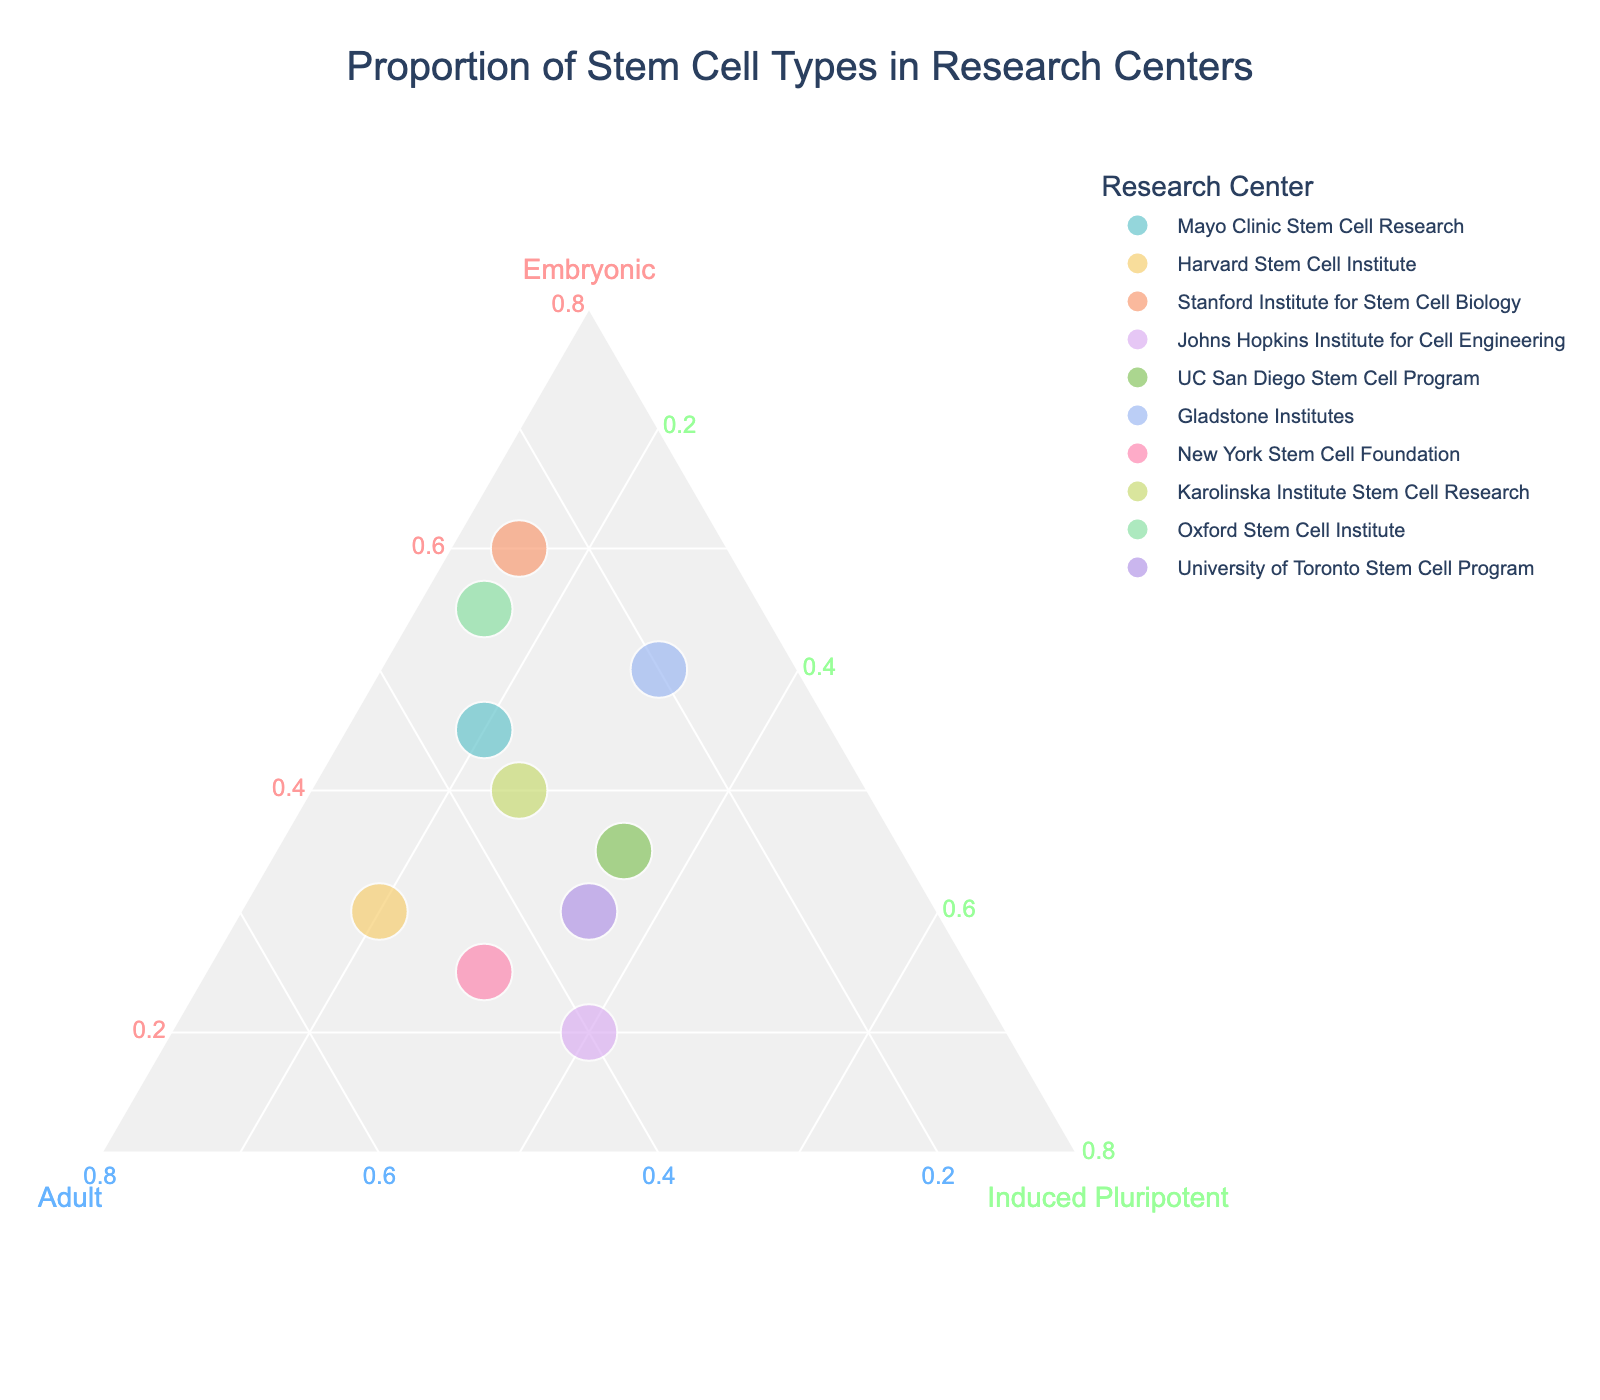What is the title of the ternary plot? The title of a figure is usually placed at the top of the graph and provides a summary of what the figure represents. In this case, it is "Proportion of Stem Cell Types in Research Centers".
Answer: Proportion of Stem Cell Types in Research Centers How many research centers are represented in the plot? Counting the distinct research centers shown in the plot gives us the total number of data points. Each research center has one corresponding point.
Answer: 10 Which research center primarily uses embryonic stem cells the most? Look for the point that is closest to the vertex labeled "Embryonic". This represents the center with the highest proportion of embryonic stem cells. Stanford Institute for Stem Cell Biology is the closest.
Answer: Stanford Institute for Stem Cell Biology How does the proportion of induced pluripotent stem cells at Johns Hopkins compare to Harvard? Identify the points for Johns Hopkins Institute for Cell Engineering and Harvard Stem Cell Institute and compare their positions along the induced pluripotent axis. Johns Hopkins has a higher proportion of induced pluripotent stem cells.
Answer: Johns Hopkins has a higher proportion Which research center has an equal proportion of adult and induced pluripotent stem cells? Find the point that lies on the line where the proportions of adult and induced pluripotent stem cells are equal. UC San Diego Stem Cell Program has an equal proportion of these cells (both at 35%).
Answer: UC San Diego Stem Cell Program What is the range of proportions for adult stem cells across all research centers? Identify the minimum and maximum values for adult stem cells from the plot by observing the points along the "Adult" axis. The lowest value is 20% (Gladstone Institutes, Stanford Institute for Stem Cell Biology), and the highest is 50% (Harvard Stem Cell Institute).
Answer: 20% to 50% Which two research centers have the closest proportions for all three types of stem cells? Look for points that are positioned very close to each other on the ternary plot, indicating similar proportions of embryonic, adult, and induced pluripotent stem cells. The UC San Diego Stem Cell Program and University of Toronto Stem Cell Program are close to each other.
Answer: UC San Diego Stem Cell Program and University of Toronto Stem Cell Program What is the average proportion of embryonic stem cells among all research centers? Sum the proportions of embryonic stem cells for all research centers and divide by the total number of research centers: (45+30+60+20+35+50+25+40+55+30)/10 = 39%
Answer: 39% Which research center has the most balanced use of all three types of stem cells? Look for the point that is closest to the center of the ternary plot, indicating a more balanced proportion of all three types of stem cells. Johns Hopkins Institute for Cell Engineering is near the center with proportions of 20%, 40%, and 40%.
Answer: Johns Hopkins Institute for Cell Engineering Which center uses the least amount of induced pluripotent stem cells? Identify the point that is closest to the vertex opposite the "Induced Pluripotent" axis since this indicates a low proportion. Stanford Institute for Stem Cell Biology and Oxford Stem Cell Institute both are close to here with 15%.
Answer: Stanford Institute for Stem Cell Biology and Oxford Stem Cell Institute 